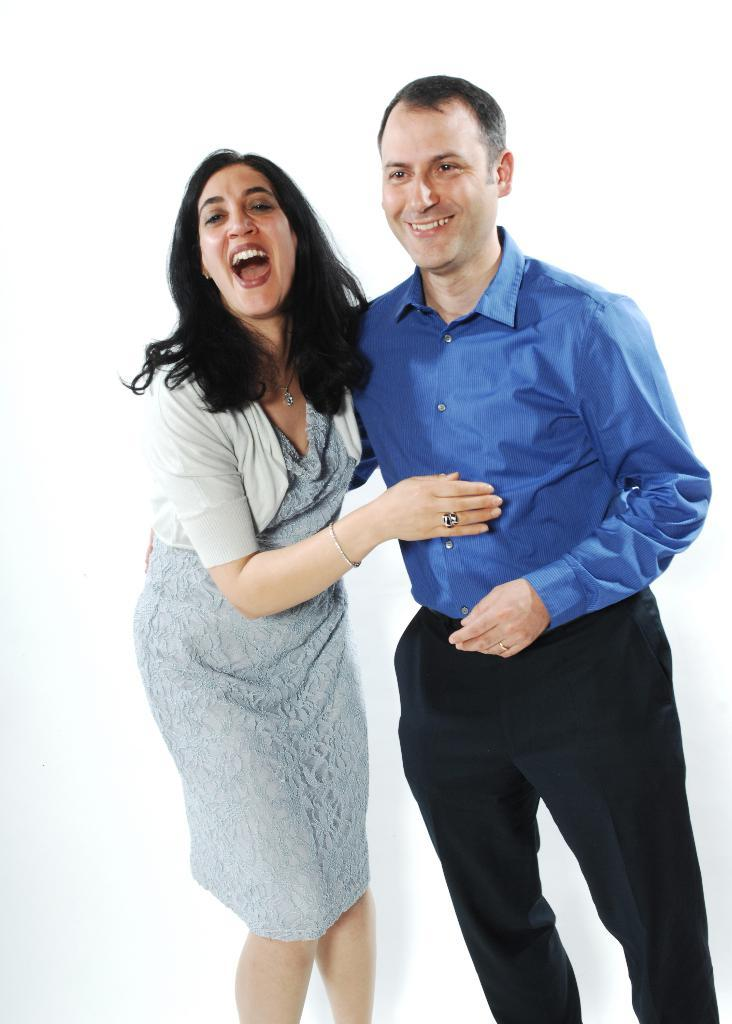What is the gender of the person in the image wearing a blue shirt? The person wearing a blue shirt is a man. What color is the man's shirt in the image? The man is wearing a blue shirt. What is the woman in the image wearing? The woman is wearing a grey dress. What type of accessory is the woman wearing in the image? The woman is wearing jewelry. What type of spark can be seen coming from the man's shirt in the image? There is no spark present in the image; the man is simply wearing a blue shirt. Is there a giraffe visible in the image? No, there is no giraffe present in the image. 